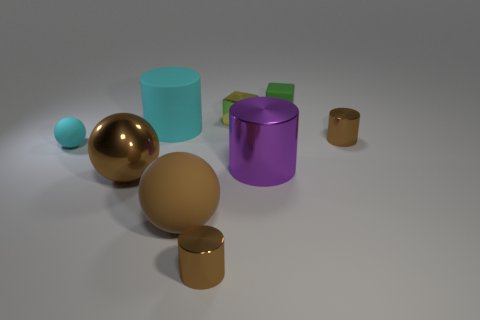Subtract all metallic cylinders. How many cylinders are left? 1 Subtract all cyan cylinders. How many cylinders are left? 3 Subtract all cylinders. How many objects are left? 5 Add 9 cyan cylinders. How many cyan cylinders exist? 10 Add 1 green cylinders. How many objects exist? 10 Subtract 0 yellow spheres. How many objects are left? 9 Subtract 2 blocks. How many blocks are left? 0 Subtract all blue cylinders. Subtract all green spheres. How many cylinders are left? 4 Subtract all brown balls. How many blue cubes are left? 0 Subtract all yellow things. Subtract all large objects. How many objects are left? 4 